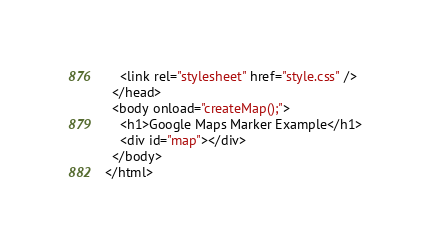<code> <loc_0><loc_0><loc_500><loc_500><_HTML_>    <link rel="stylesheet" href="style.css" />
  </head>
  <body onload="createMap();">
    <h1>Google Maps Marker Example</h1>
    <div id="map"></div>
  </body>
</html>
</code> 